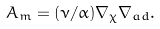<formula> <loc_0><loc_0><loc_500><loc_500>A _ { m } = ( \nu / \alpha ) \nabla _ { \chi } \nabla _ { a d } .</formula> 